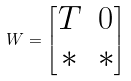<formula> <loc_0><loc_0><loc_500><loc_500>W = \begin{bmatrix} T & 0 \\ * & * \end{bmatrix}</formula> 